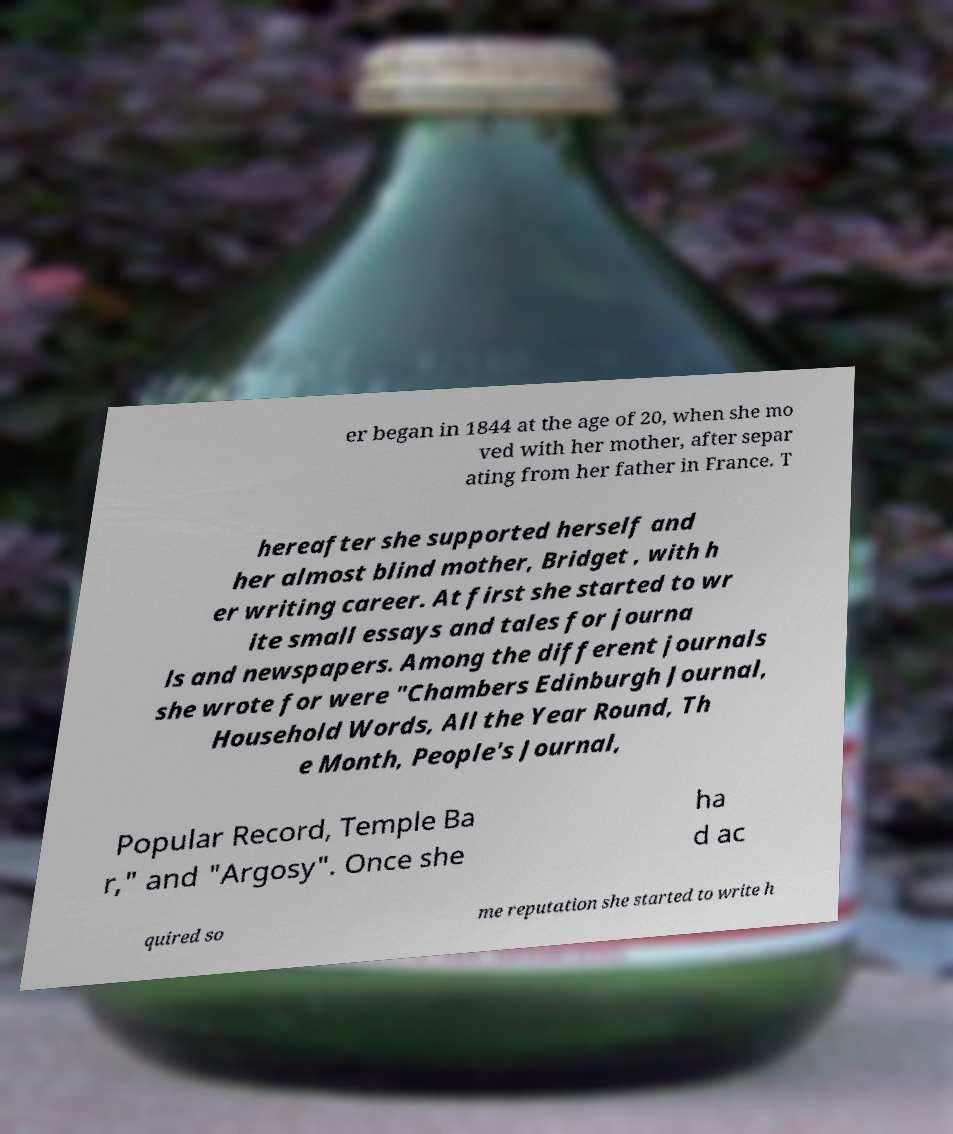I need the written content from this picture converted into text. Can you do that? er began in 1844 at the age of 20, when she mo ved with her mother, after separ ating from her father in France. T hereafter she supported herself and her almost blind mother, Bridget , with h er writing career. At first she started to wr ite small essays and tales for journa ls and newspapers. Among the different journals she wrote for were "Chambers Edinburgh Journal, Household Words, All the Year Round, Th e Month, People's Journal, Popular Record, Temple Ba r," and "Argosy". Once she ha d ac quired so me reputation she started to write h 